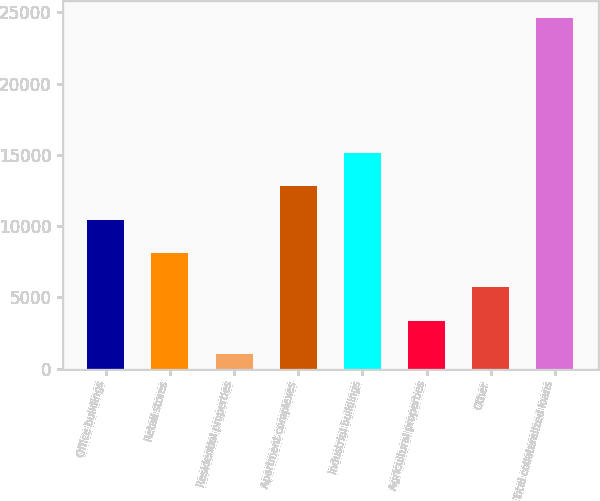Convert chart to OTSL. <chart><loc_0><loc_0><loc_500><loc_500><bar_chart><fcel>Office buildings<fcel>Retail stores<fcel>Residential properties<fcel>Apartment complexes<fcel>Industrial buildings<fcel>Agricultural properties<fcel>Other<fcel>Total collateralized loans<nl><fcel>10437<fcel>8077.5<fcel>999<fcel>12796.5<fcel>15156<fcel>3358.5<fcel>5718<fcel>24594<nl></chart> 